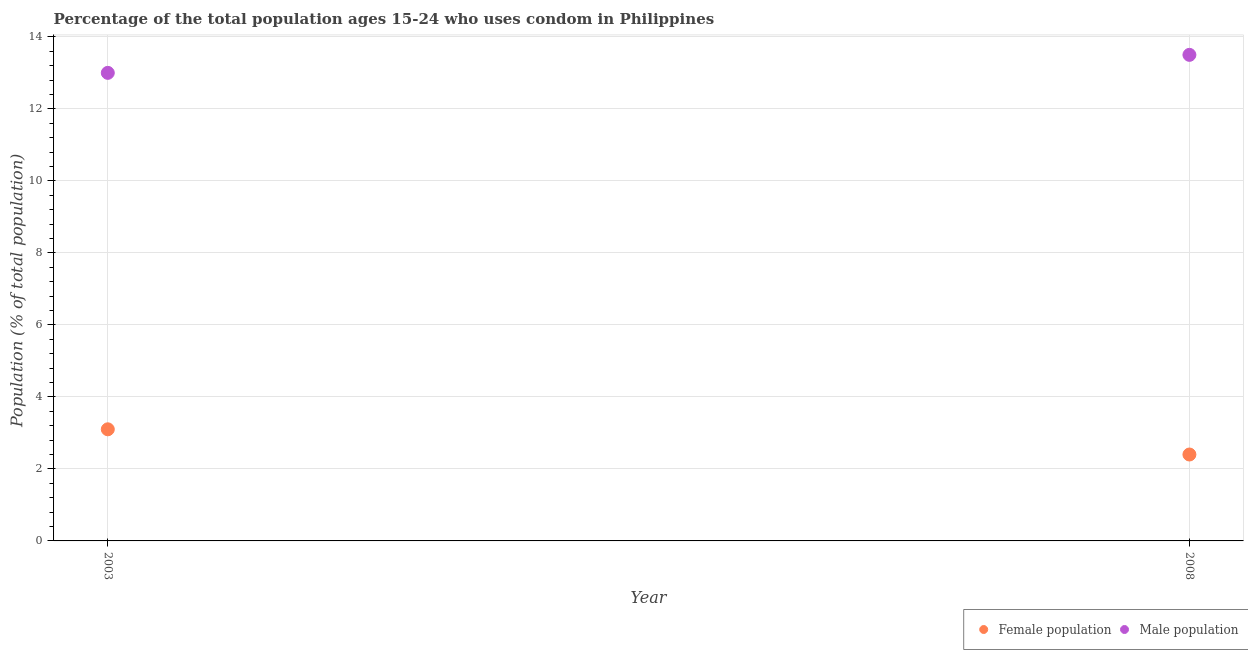In which year was the female population maximum?
Give a very brief answer. 2003. In which year was the female population minimum?
Your answer should be compact. 2008. What is the difference between the female population in 2003 and that in 2008?
Your answer should be compact. 0.7. What is the average female population per year?
Keep it short and to the point. 2.75. What is the ratio of the male population in 2003 to that in 2008?
Your response must be concise. 0.96. Is the female population in 2003 less than that in 2008?
Provide a succinct answer. No. Does the female population monotonically increase over the years?
Ensure brevity in your answer.  No. Is the female population strictly less than the male population over the years?
Offer a very short reply. Yes. How many dotlines are there?
Your answer should be compact. 2. Are the values on the major ticks of Y-axis written in scientific E-notation?
Make the answer very short. No. Where does the legend appear in the graph?
Give a very brief answer. Bottom right. What is the title of the graph?
Ensure brevity in your answer.  Percentage of the total population ages 15-24 who uses condom in Philippines. What is the label or title of the Y-axis?
Ensure brevity in your answer.  Population (% of total population) . What is the Population (% of total population)  in Female population in 2003?
Your answer should be very brief. 3.1. What is the Population (% of total population)  of Male population in 2008?
Offer a very short reply. 13.5. Across all years, what is the maximum Population (% of total population)  of Male population?
Make the answer very short. 13.5. Across all years, what is the minimum Population (% of total population)  in Male population?
Offer a very short reply. 13. What is the difference between the Population (% of total population)  of Female population in 2003 and that in 2008?
Make the answer very short. 0.7. What is the difference between the Population (% of total population)  in Male population in 2003 and that in 2008?
Offer a terse response. -0.5. What is the average Population (% of total population)  of Female population per year?
Provide a succinct answer. 2.75. What is the average Population (% of total population)  in Male population per year?
Provide a short and direct response. 13.25. In the year 2003, what is the difference between the Population (% of total population)  in Female population and Population (% of total population)  in Male population?
Your answer should be very brief. -9.9. What is the ratio of the Population (% of total population)  in Female population in 2003 to that in 2008?
Provide a succinct answer. 1.29. What is the ratio of the Population (% of total population)  in Male population in 2003 to that in 2008?
Offer a terse response. 0.96. 